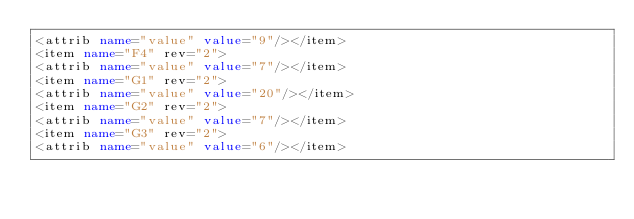Convert code to text. <code><loc_0><loc_0><loc_500><loc_500><_XML_><attrib name="value" value="9"/></item>
<item name="F4" rev="2">
<attrib name="value" value="7"/></item>
<item name="G1" rev="2">
<attrib name="value" value="20"/></item>
<item name="G2" rev="2">
<attrib name="value" value="7"/></item>
<item name="G3" rev="2">
<attrib name="value" value="6"/></item></code> 